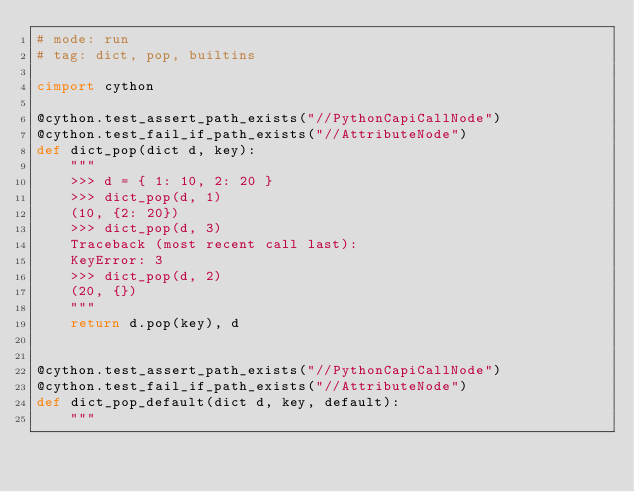<code> <loc_0><loc_0><loc_500><loc_500><_Cython_># mode: run
# tag: dict, pop, builtins

cimport cython

@cython.test_assert_path_exists("//PythonCapiCallNode")
@cython.test_fail_if_path_exists("//AttributeNode")
def dict_pop(dict d, key):
    """
    >>> d = { 1: 10, 2: 20 }
    >>> dict_pop(d, 1)
    (10, {2: 20})
    >>> dict_pop(d, 3)
    Traceback (most recent call last):
    KeyError: 3
    >>> dict_pop(d, 2)
    (20, {})
    """
    return d.pop(key), d


@cython.test_assert_path_exists("//PythonCapiCallNode")
@cython.test_fail_if_path_exists("//AttributeNode")
def dict_pop_default(dict d, key, default):
    """</code> 